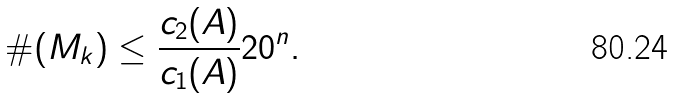Convert formula to latex. <formula><loc_0><loc_0><loc_500><loc_500>\# ( M _ { k } ) \leq \frac { c _ { 2 } ( A ) } { c _ { 1 } ( A ) } 2 0 ^ { n } .</formula> 